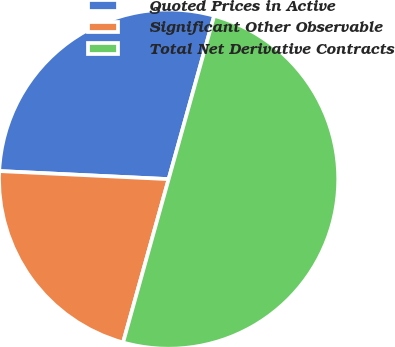Convert chart to OTSL. <chart><loc_0><loc_0><loc_500><loc_500><pie_chart><fcel>Quoted Prices in Active<fcel>Significant Other Observable<fcel>Total Net Derivative Contracts<nl><fcel>28.57%<fcel>21.43%<fcel>50.0%<nl></chart> 